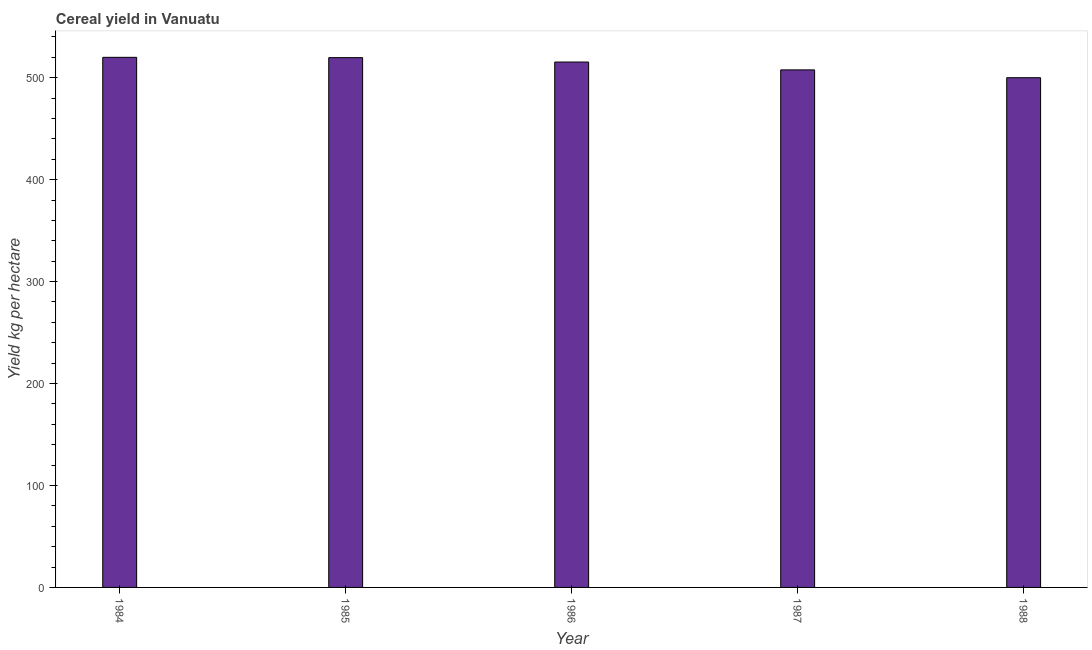Does the graph contain any zero values?
Keep it short and to the point. No. What is the title of the graph?
Make the answer very short. Cereal yield in Vanuatu. What is the label or title of the X-axis?
Keep it short and to the point. Year. What is the label or title of the Y-axis?
Provide a succinct answer. Yield kg per hectare. What is the cereal yield in 1986?
Give a very brief answer. 515.38. Across all years, what is the maximum cereal yield?
Your response must be concise. 520. Across all years, what is the minimum cereal yield?
Give a very brief answer. 500. In which year was the cereal yield maximum?
Your answer should be compact. 1984. What is the sum of the cereal yield?
Provide a short and direct response. 2562.76. What is the average cereal yield per year?
Ensure brevity in your answer.  512.55. What is the median cereal yield?
Give a very brief answer. 515.38. Do a majority of the years between 1986 and 1984 (inclusive) have cereal yield greater than 400 kg per hectare?
Your answer should be very brief. Yes. What is the ratio of the cereal yield in 1985 to that in 1988?
Provide a succinct answer. 1.04. Is the cereal yield in 1984 less than that in 1988?
Offer a very short reply. No. What is the difference between the highest and the second highest cereal yield?
Ensure brevity in your answer.  0.32. Are all the bars in the graph horizontal?
Provide a short and direct response. No. What is the difference between two consecutive major ticks on the Y-axis?
Offer a terse response. 100. Are the values on the major ticks of Y-axis written in scientific E-notation?
Offer a very short reply. No. What is the Yield kg per hectare in 1984?
Make the answer very short. 520. What is the Yield kg per hectare of 1985?
Keep it short and to the point. 519.68. What is the Yield kg per hectare in 1986?
Keep it short and to the point. 515.38. What is the Yield kg per hectare in 1987?
Your response must be concise. 507.69. What is the Yield kg per hectare in 1988?
Give a very brief answer. 500. What is the difference between the Yield kg per hectare in 1984 and 1985?
Your answer should be very brief. 0.32. What is the difference between the Yield kg per hectare in 1984 and 1986?
Your answer should be compact. 4.62. What is the difference between the Yield kg per hectare in 1984 and 1987?
Offer a very short reply. 12.31. What is the difference between the Yield kg per hectare in 1985 and 1987?
Offer a terse response. 11.99. What is the difference between the Yield kg per hectare in 1985 and 1988?
Your answer should be compact. 19.68. What is the difference between the Yield kg per hectare in 1986 and 1987?
Your answer should be compact. 7.69. What is the difference between the Yield kg per hectare in 1986 and 1988?
Your answer should be compact. 15.38. What is the difference between the Yield kg per hectare in 1987 and 1988?
Your response must be concise. 7.69. What is the ratio of the Yield kg per hectare in 1984 to that in 1985?
Your answer should be very brief. 1. What is the ratio of the Yield kg per hectare in 1984 to that in 1986?
Offer a very short reply. 1.01. What is the ratio of the Yield kg per hectare in 1984 to that in 1987?
Offer a terse response. 1.02. What is the ratio of the Yield kg per hectare in 1984 to that in 1988?
Provide a succinct answer. 1.04. What is the ratio of the Yield kg per hectare in 1985 to that in 1986?
Your answer should be compact. 1.01. What is the ratio of the Yield kg per hectare in 1985 to that in 1987?
Provide a succinct answer. 1.02. What is the ratio of the Yield kg per hectare in 1985 to that in 1988?
Offer a terse response. 1.04. What is the ratio of the Yield kg per hectare in 1986 to that in 1987?
Provide a succinct answer. 1.01. What is the ratio of the Yield kg per hectare in 1986 to that in 1988?
Ensure brevity in your answer.  1.03. 